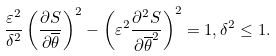<formula> <loc_0><loc_0><loc_500><loc_500>\frac { \varepsilon ^ { 2 } } { \delta ^ { 2 } } \left ( \frac { \partial S } { \partial \overline { \theta } } \right ) ^ { 2 } - \left ( \varepsilon ^ { 2 } \frac { \partial ^ { 2 } S } { \partial \overline { \theta } ^ { 2 } } \right ) ^ { 2 } = 1 , \delta ^ { 2 } \leq 1 .</formula> 